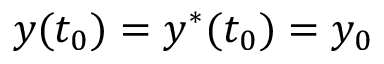Convert formula to latex. <formula><loc_0><loc_0><loc_500><loc_500>y ( t _ { 0 } ) = y ^ { * } ( t _ { 0 } ) = y _ { 0 }</formula> 